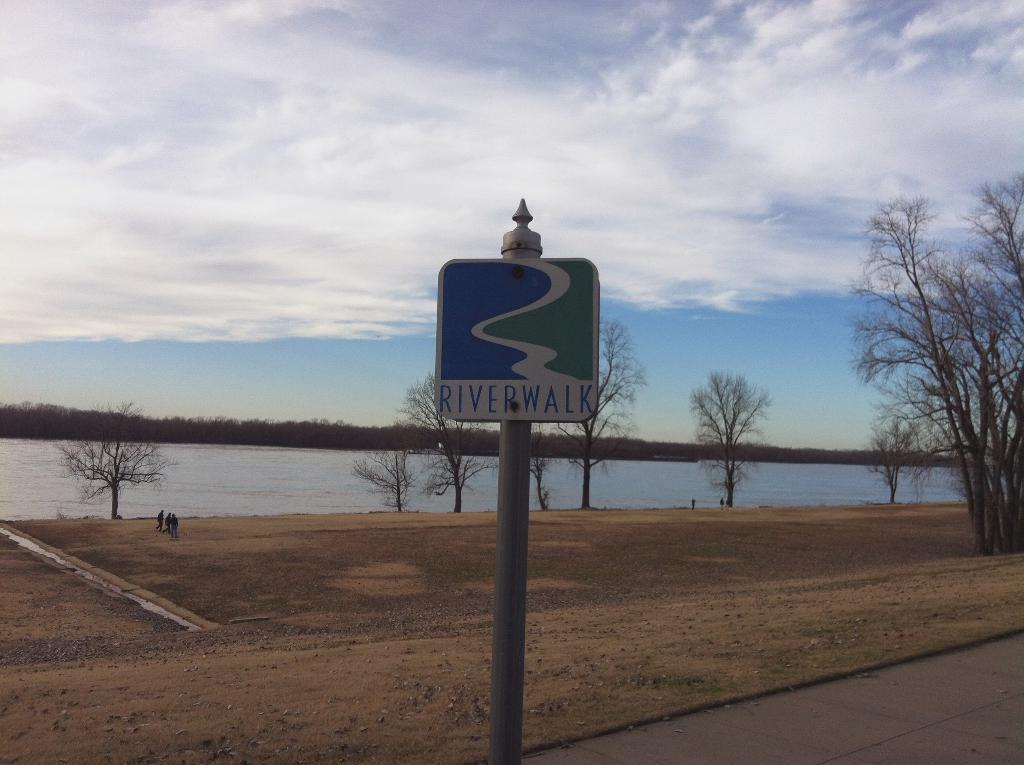Could you give a brief overview of what you see in this image? At the bottom of the image there is a path and a pole with name board. Behind the pole on the ground there are stones and also there are few people standing. There are trees. Behind them there is water. Behind the water there are tree. At the top of the image there is sky. 